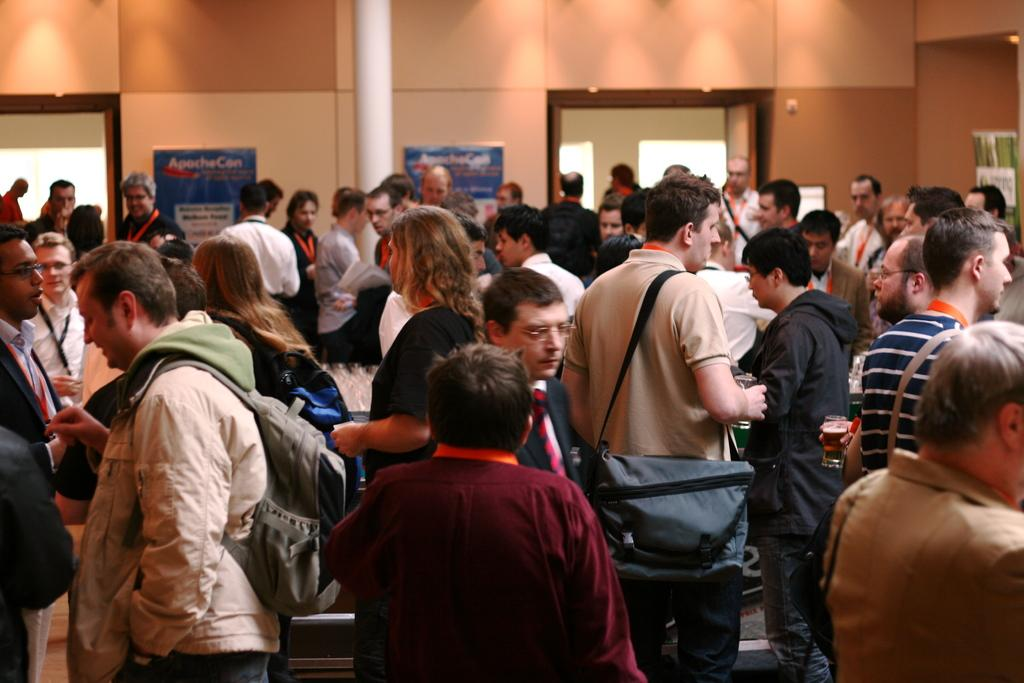What is happening in the image? There is a group of people standing in the image. What can be seen in the background of the image? There are banners, a pole, a wall, and two entrances visible in the background of the image. What type of shoes are the people wearing in the image? There is no information about the shoes the people are wearing in the image. 